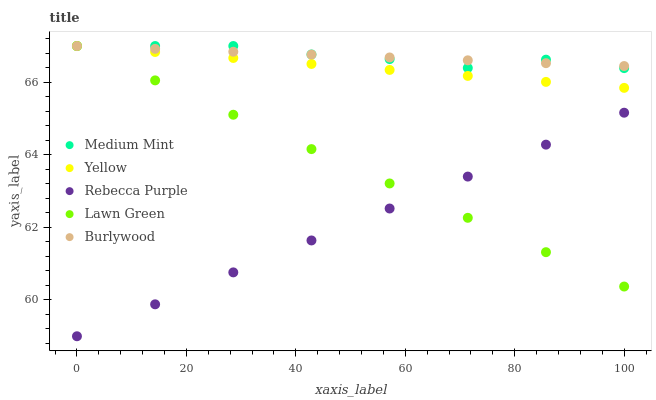Does Rebecca Purple have the minimum area under the curve?
Answer yes or no. Yes. Does Medium Mint have the maximum area under the curve?
Answer yes or no. Yes. Does Lawn Green have the minimum area under the curve?
Answer yes or no. No. Does Lawn Green have the maximum area under the curve?
Answer yes or no. No. Is Burlywood the smoothest?
Answer yes or no. Yes. Is Medium Mint the roughest?
Answer yes or no. Yes. Is Lawn Green the smoothest?
Answer yes or no. No. Is Lawn Green the roughest?
Answer yes or no. No. Does Rebecca Purple have the lowest value?
Answer yes or no. Yes. Does Lawn Green have the lowest value?
Answer yes or no. No. Does Yellow have the highest value?
Answer yes or no. Yes. Does Rebecca Purple have the highest value?
Answer yes or no. No. Is Rebecca Purple less than Medium Mint?
Answer yes or no. Yes. Is Burlywood greater than Rebecca Purple?
Answer yes or no. Yes. Does Medium Mint intersect Lawn Green?
Answer yes or no. Yes. Is Medium Mint less than Lawn Green?
Answer yes or no. No. Is Medium Mint greater than Lawn Green?
Answer yes or no. No. Does Rebecca Purple intersect Medium Mint?
Answer yes or no. No. 